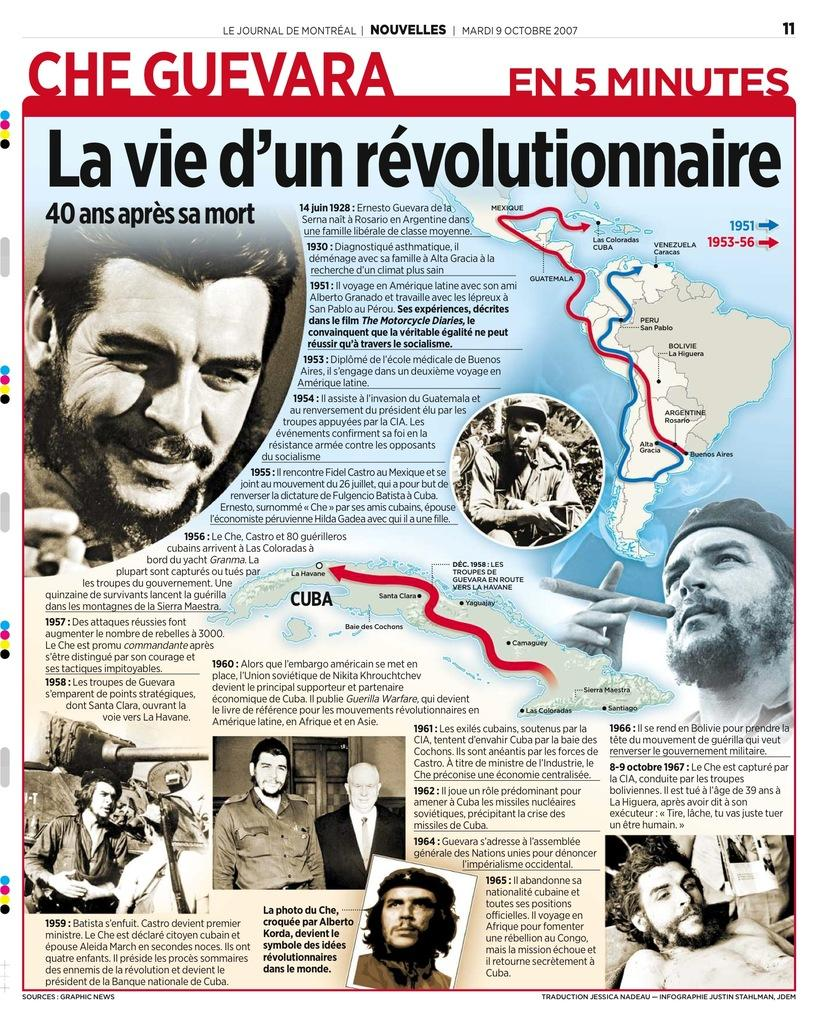What type of visual is the image? The image is a poster. What can be found on the poster besides images? There is text written on the poster. What type of images are present on the poster? There are images of persons on the poster. How does the water system work in the image? There is no water system present in the image; it is a poster with text and images of persons. What day of the week is depicted in the image? The day of the week is not depicted in the image, as it is a poster with text and images of persons. 